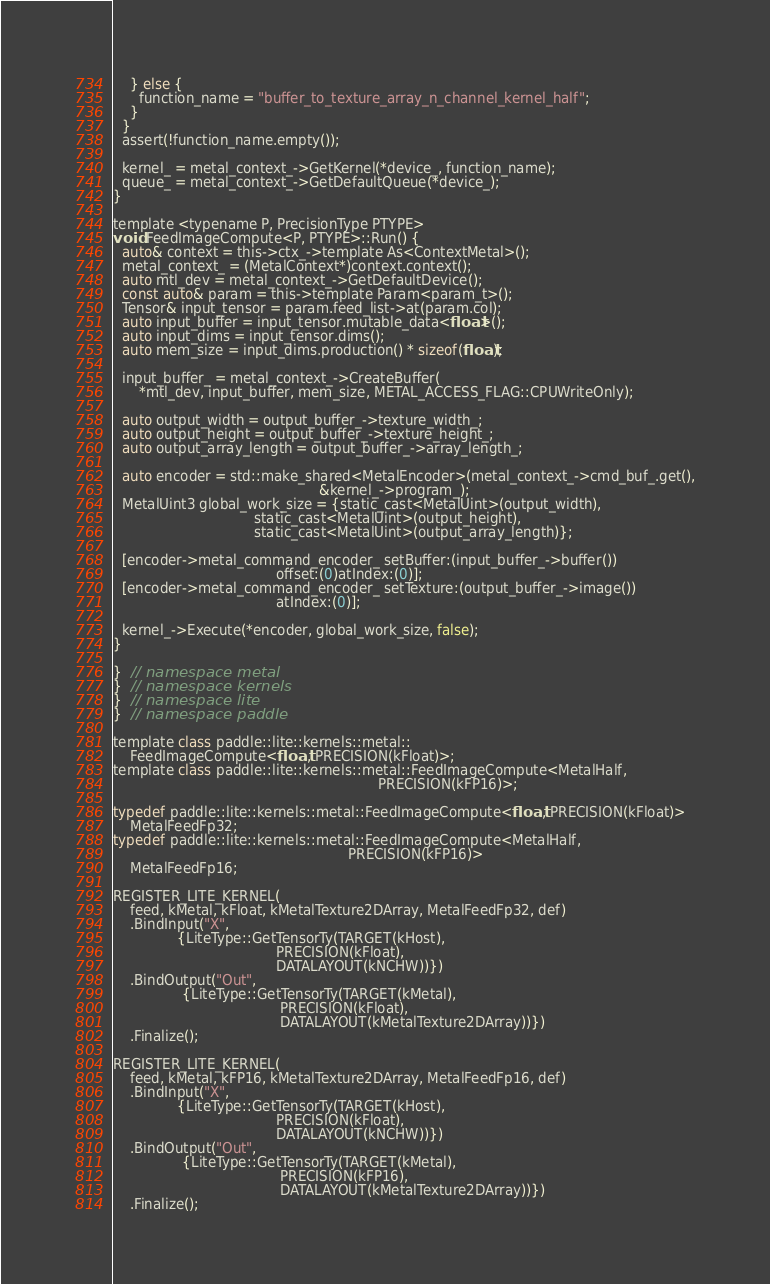<code> <loc_0><loc_0><loc_500><loc_500><_ObjectiveC_>    } else {
      function_name = "buffer_to_texture_array_n_channel_kernel_half";
    }
  }
  assert(!function_name.empty());

  kernel_ = metal_context_->GetKernel(*device_, function_name);
  queue_ = metal_context_->GetDefaultQueue(*device_);
}

template <typename P, PrecisionType PTYPE>
void FeedImageCompute<P, PTYPE>::Run() {
  auto& context = this->ctx_->template As<ContextMetal>();
  metal_context_ = (MetalContext*)context.context();
  auto mtl_dev = metal_context_->GetDefaultDevice();
  const auto& param = this->template Param<param_t>();
  Tensor& input_tensor = param.feed_list->at(param.col);
  auto input_buffer = input_tensor.mutable_data<float>();
  auto input_dims = input_tensor.dims();
  auto mem_size = input_dims.production() * sizeof(float);

  input_buffer_ = metal_context_->CreateBuffer(
      *mtl_dev, input_buffer, mem_size, METAL_ACCESS_FLAG::CPUWriteOnly);

  auto output_width = output_buffer_->texture_width_;
  auto output_height = output_buffer_->texture_height_;
  auto output_array_length = output_buffer_->array_length_;

  auto encoder = std::make_shared<MetalEncoder>(metal_context_->cmd_buf_.get(),
                                                &kernel_->program_);
  MetalUint3 global_work_size = {static_cast<MetalUint>(output_width),
                                 static_cast<MetalUint>(output_height),
                                 static_cast<MetalUint>(output_array_length)};

  [encoder->metal_command_encoder_ setBuffer:(input_buffer_->buffer())
                                      offset:(0)atIndex:(0)];
  [encoder->metal_command_encoder_ setTexture:(output_buffer_->image())
                                      atIndex:(0)];

  kernel_->Execute(*encoder, global_work_size, false);
}

}  // namespace metal
}  // namespace kernels
}  // namespace lite
}  // namespace paddle

template class paddle::lite::kernels::metal::
    FeedImageCompute<float, PRECISION(kFloat)>;
template class paddle::lite::kernels::metal::FeedImageCompute<MetalHalf,
                                                              PRECISION(kFP16)>;

typedef paddle::lite::kernels::metal::FeedImageCompute<float, PRECISION(kFloat)>
    MetalFeedFp32;
typedef paddle::lite::kernels::metal::FeedImageCompute<MetalHalf,
                                                       PRECISION(kFP16)>
    MetalFeedFp16;

REGISTER_LITE_KERNEL(
    feed, kMetal, kFloat, kMetalTexture2DArray, MetalFeedFp32, def)
    .BindInput("X",
               {LiteType::GetTensorTy(TARGET(kHost),
                                      PRECISION(kFloat),
                                      DATALAYOUT(kNCHW))})
    .BindOutput("Out",
                {LiteType::GetTensorTy(TARGET(kMetal),
                                       PRECISION(kFloat),
                                       DATALAYOUT(kMetalTexture2DArray))})
    .Finalize();

REGISTER_LITE_KERNEL(
    feed, kMetal, kFP16, kMetalTexture2DArray, MetalFeedFp16, def)
    .BindInput("X",
               {LiteType::GetTensorTy(TARGET(kHost),
                                      PRECISION(kFloat),
                                      DATALAYOUT(kNCHW))})
    .BindOutput("Out",
                {LiteType::GetTensorTy(TARGET(kMetal),
                                       PRECISION(kFP16),
                                       DATALAYOUT(kMetalTexture2DArray))})
    .Finalize();
</code> 